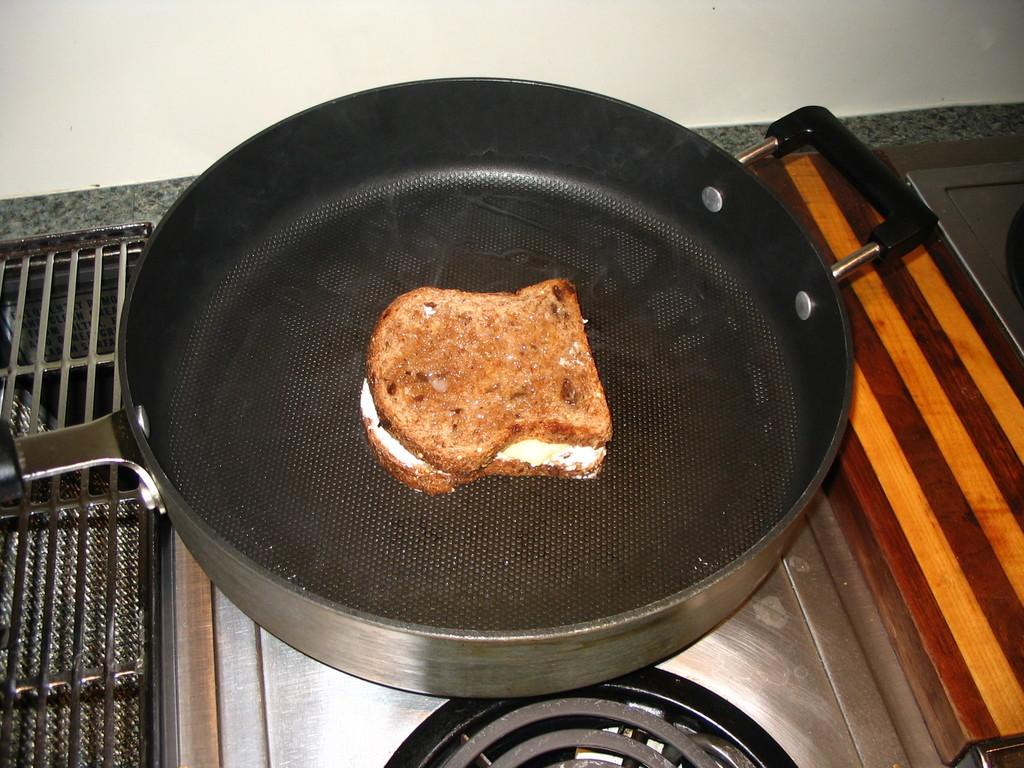What is on the pan that is visible in the image? There is a sandwich on a pan in the image. Where is the pan located in the image? The pan is on a stove in the image. What can be seen at the top of the image? There is a white wall visible at the top of the image. What is on the left side of the image? There is a grill on the left side of the image. What type of throat-soothing remedy is being prepared on the grill in the image? There is no throat-soothing remedy being prepared in the image; the grill is not being used for that purpose. 